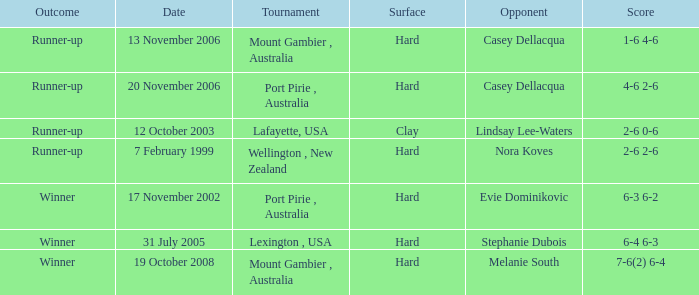When is a competitor of evie dominikovic? 17 November 2002. 